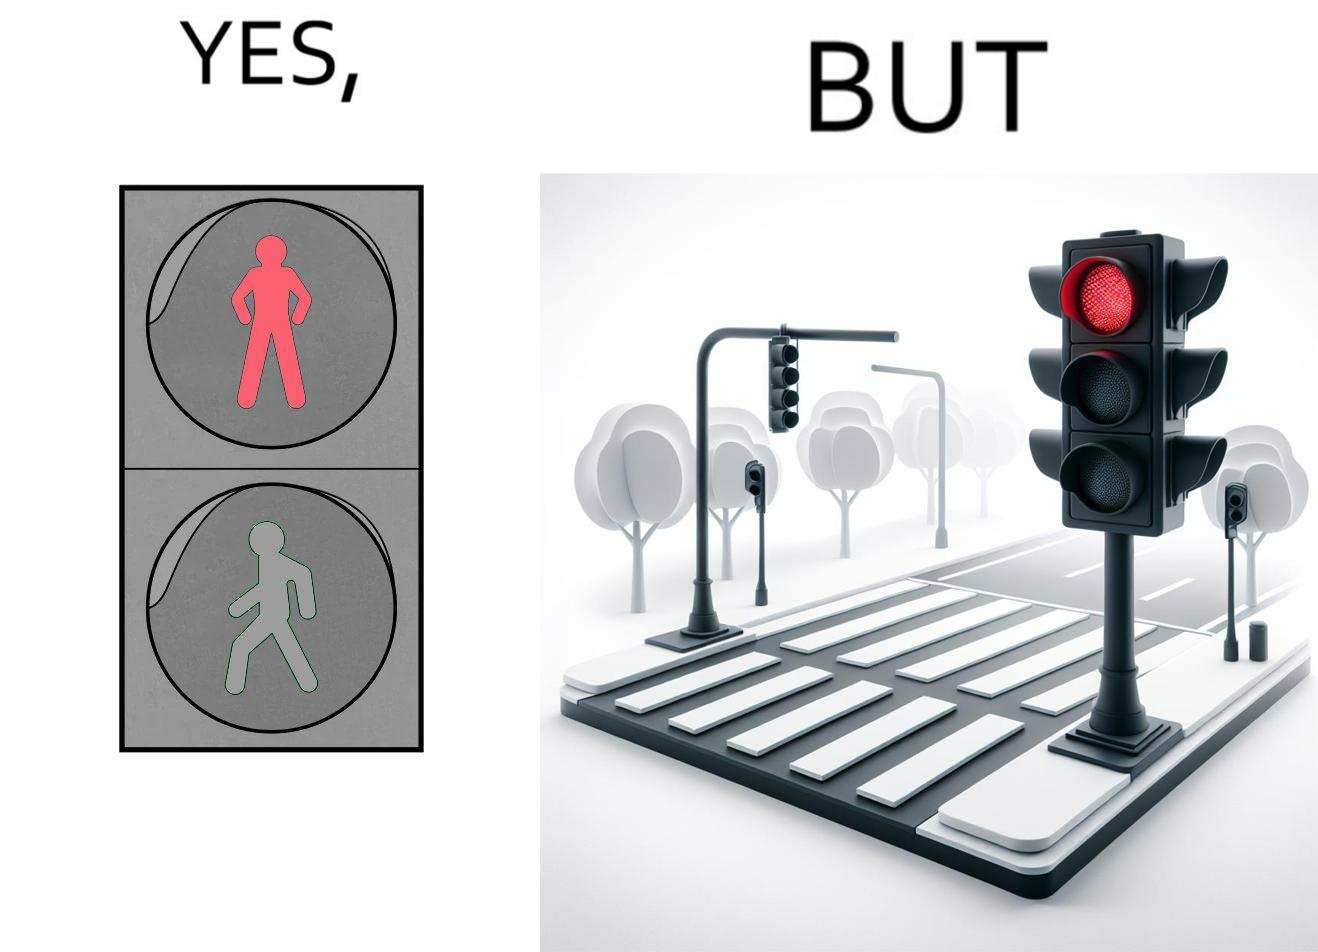Describe what you see in the left and right parts of this image. In the left part of the image: red traffic light for stopping a person from crossing the street. In the right part of the image: a red traffic light at a zebra crossing, with no persons or vehicles around. 